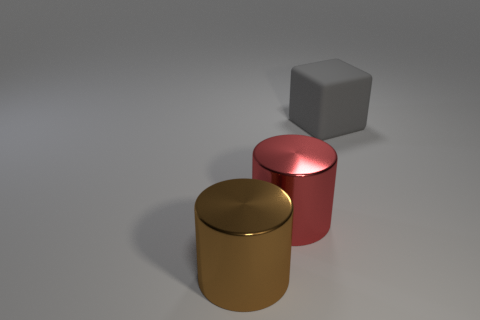Are there any other shiny things that have the same shape as the large brown shiny object?
Offer a very short reply. Yes. There is a brown metal thing that is the same size as the gray matte block; what shape is it?
Your response must be concise. Cylinder. What number of other big rubber cubes are the same color as the matte block?
Your answer should be very brief. 0. There is a metallic cylinder that is right of the big brown cylinder; what is its size?
Give a very brief answer. Large. How many metal cylinders have the same size as the gray object?
Ensure brevity in your answer.  2. What is the color of the other object that is the same material as the brown object?
Make the answer very short. Red. Is the number of gray things that are left of the large brown cylinder less than the number of tiny blue rubber blocks?
Make the answer very short. No. There is a large brown object that is made of the same material as the large red object; what is its shape?
Offer a very short reply. Cylinder. How many matte things are large brown objects or small red balls?
Provide a succinct answer. 0. Are there the same number of rubber blocks that are to the left of the gray object and large objects?
Provide a succinct answer. No. 